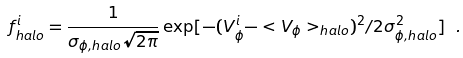Convert formula to latex. <formula><loc_0><loc_0><loc_500><loc_500>f _ { h a l o } ^ { i } = \frac { 1 } { \sigma _ { \phi , { h a l o } } \sqrt { 2 \pi } } \exp [ - ( V _ { \phi } ^ { i } - < V _ { \phi } > _ { h a l o } ) ^ { 2 } / 2 \sigma _ { \phi , { h a l o } } ^ { 2 } ] \ .</formula> 